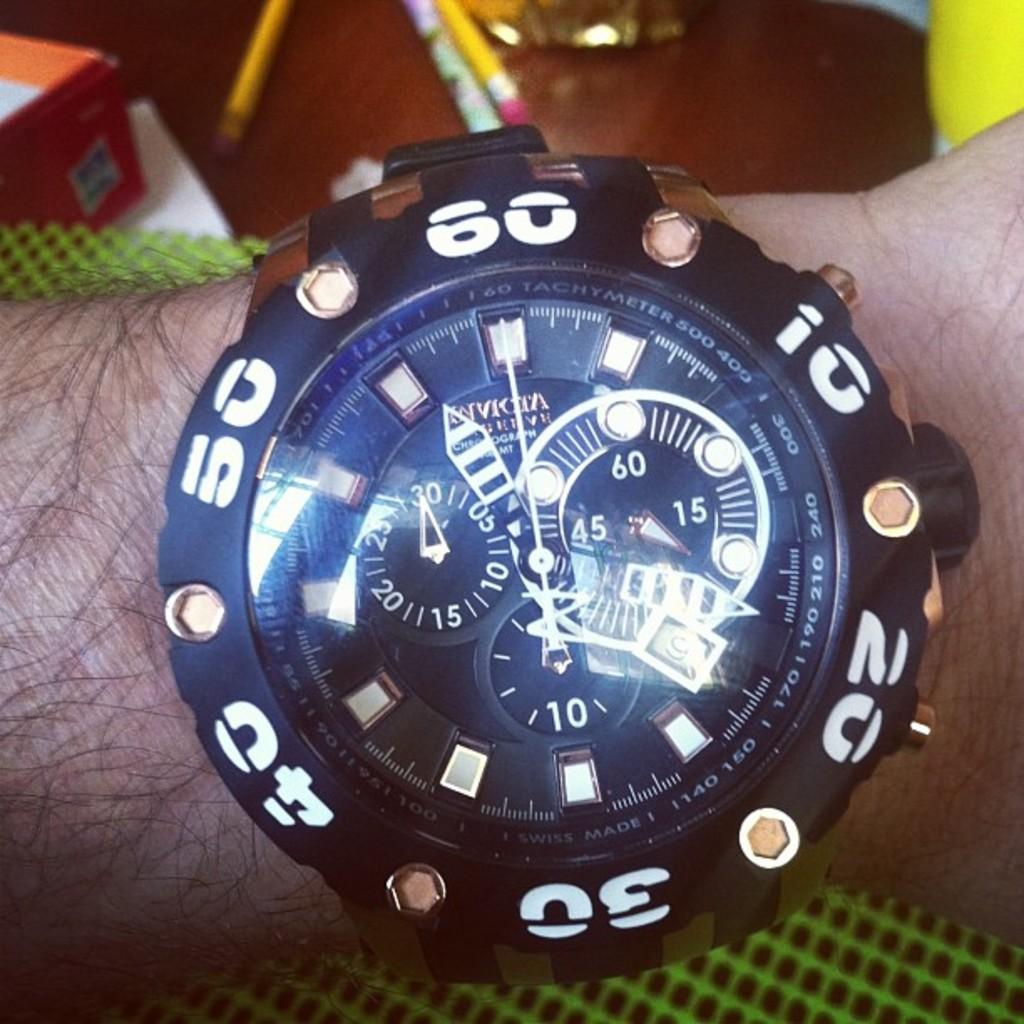<image>
Summarize the visual content of the image. A man is wearing a watch that says Invicta on the face. 